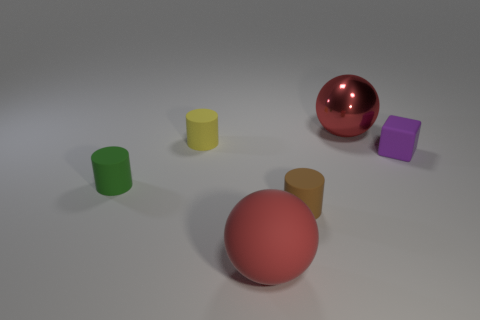There is a thing that is the same color as the matte sphere; what material is it?
Make the answer very short. Metal. How many things are either metal things or large blocks?
Your answer should be very brief. 1. What is the shape of the large thing to the left of the red object that is right of the ball in front of the small yellow rubber cylinder?
Offer a terse response. Sphere. Is the big red object that is left of the small brown matte object made of the same material as the yellow cylinder in front of the red shiny ball?
Offer a very short reply. Yes. There is a yellow thing that is the same shape as the brown object; what is its material?
Keep it short and to the point. Rubber. Are there any other things that are the same size as the matte sphere?
Keep it short and to the point. Yes. Does the big object on the right side of the red rubber object have the same shape as the green rubber object behind the red rubber ball?
Provide a succinct answer. No. Are there fewer cylinders that are left of the red metal thing than rubber cylinders right of the green cylinder?
Provide a succinct answer. No. What number of other objects are the same shape as the purple thing?
Offer a terse response. 0. There is a tiny green thing that is made of the same material as the tiny brown thing; what is its shape?
Offer a very short reply. Cylinder. 